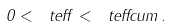<formula> <loc_0><loc_0><loc_500><loc_500>0 < \ t e f f < \ t e f f c u m \, .</formula> 